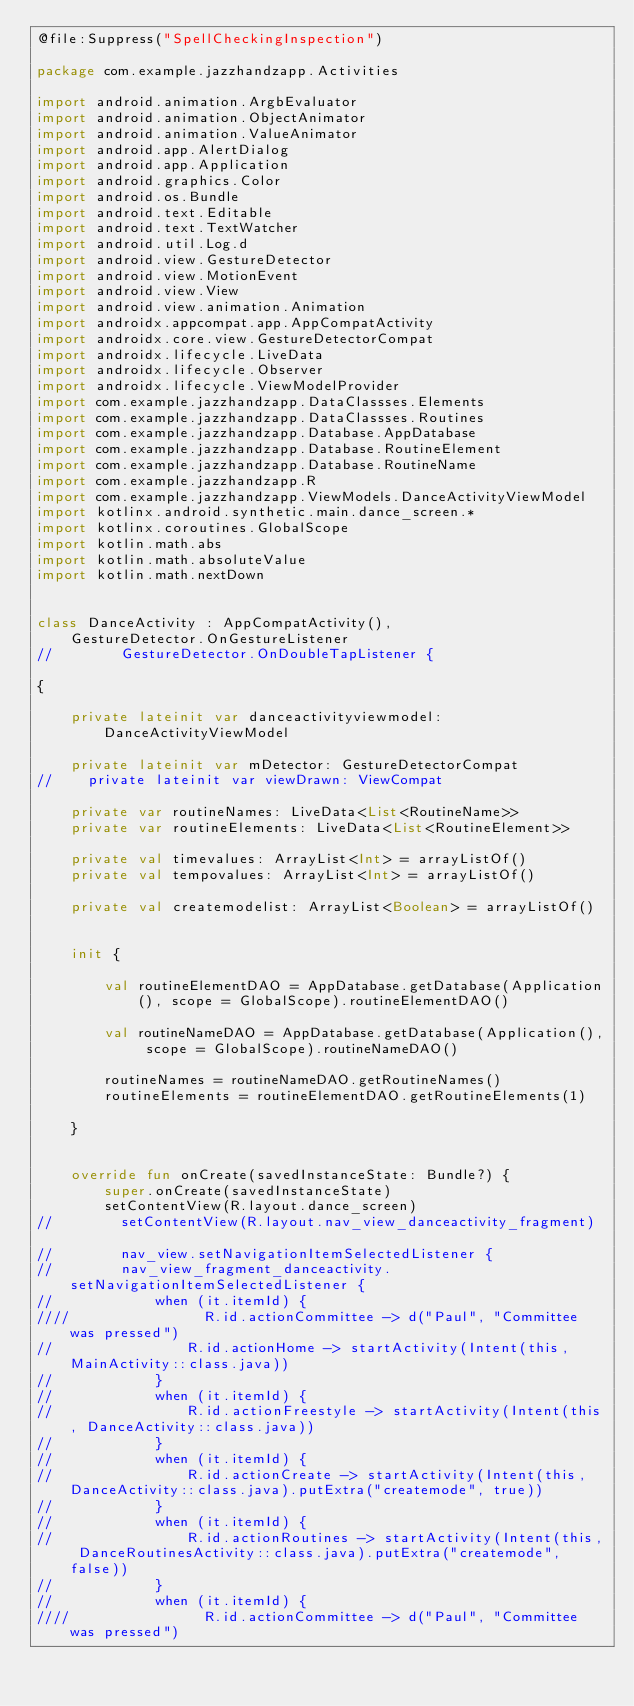<code> <loc_0><loc_0><loc_500><loc_500><_Kotlin_>@file:Suppress("SpellCheckingInspection")

package com.example.jazzhandzapp.Activities

import android.animation.ArgbEvaluator
import android.animation.ObjectAnimator
import android.animation.ValueAnimator
import android.app.AlertDialog
import android.app.Application
import android.graphics.Color
import android.os.Bundle
import android.text.Editable
import android.text.TextWatcher
import android.util.Log.d
import android.view.GestureDetector
import android.view.MotionEvent
import android.view.View
import android.view.animation.Animation
import androidx.appcompat.app.AppCompatActivity
import androidx.core.view.GestureDetectorCompat
import androidx.lifecycle.LiveData
import androidx.lifecycle.Observer
import androidx.lifecycle.ViewModelProvider
import com.example.jazzhandzapp.DataClassses.Elements
import com.example.jazzhandzapp.DataClassses.Routines
import com.example.jazzhandzapp.Database.AppDatabase
import com.example.jazzhandzapp.Database.RoutineElement
import com.example.jazzhandzapp.Database.RoutineName
import com.example.jazzhandzapp.R
import com.example.jazzhandzapp.ViewModels.DanceActivityViewModel
import kotlinx.android.synthetic.main.dance_screen.*
import kotlinx.coroutines.GlobalScope
import kotlin.math.abs
import kotlin.math.absoluteValue
import kotlin.math.nextDown


class DanceActivity : AppCompatActivity(),
    GestureDetector.OnGestureListener
//        GestureDetector.OnDoubleTapListener {

{

    private lateinit var danceactivityviewmodel: DanceActivityViewModel

    private lateinit var mDetector: GestureDetectorCompat
//    private lateinit var viewDrawn: ViewCompat

    private var routineNames: LiveData<List<RoutineName>>
    private var routineElements: LiveData<List<RoutineElement>>

    private val timevalues: ArrayList<Int> = arrayListOf()
    private val tempovalues: ArrayList<Int> = arrayListOf()

    private val createmodelist: ArrayList<Boolean> = arrayListOf()


    init {

        val routineElementDAO = AppDatabase.getDatabase(Application(), scope = GlobalScope).routineElementDAO()

        val routineNameDAO = AppDatabase.getDatabase(Application(), scope = GlobalScope).routineNameDAO()

        routineNames = routineNameDAO.getRoutineNames()
        routineElements = routineElementDAO.getRoutineElements(1)

    }


    override fun onCreate(savedInstanceState: Bundle?) {
        super.onCreate(savedInstanceState)
        setContentView(R.layout.dance_screen)
//        setContentView(R.layout.nav_view_danceactivity_fragment)

//        nav_view.setNavigationItemSelectedListener {
//        nav_view_fragment_danceactivity.setNavigationItemSelectedListener {
//            when (it.itemId) {
////                R.id.actionCommittee -> d("Paul", "Committee was pressed")
//                R.id.actionHome -> startActivity(Intent(this, MainActivity::class.java))
//            }
//            when (it.itemId) {
//                R.id.actionFreestyle -> startActivity(Intent(this, DanceActivity::class.java))
//            }
//            when (it.itemId) {
//                R.id.actionCreate -> startActivity(Intent(this, DanceActivity::class.java).putExtra("createmode", true))
//            }
//            when (it.itemId) {
//                R.id.actionRoutines -> startActivity(Intent(this, DanceRoutinesActivity::class.java).putExtra("createmode", false))
//            }
//            when (it.itemId) {
////                R.id.actionCommittee -> d("Paul", "Committee was pressed")</code> 